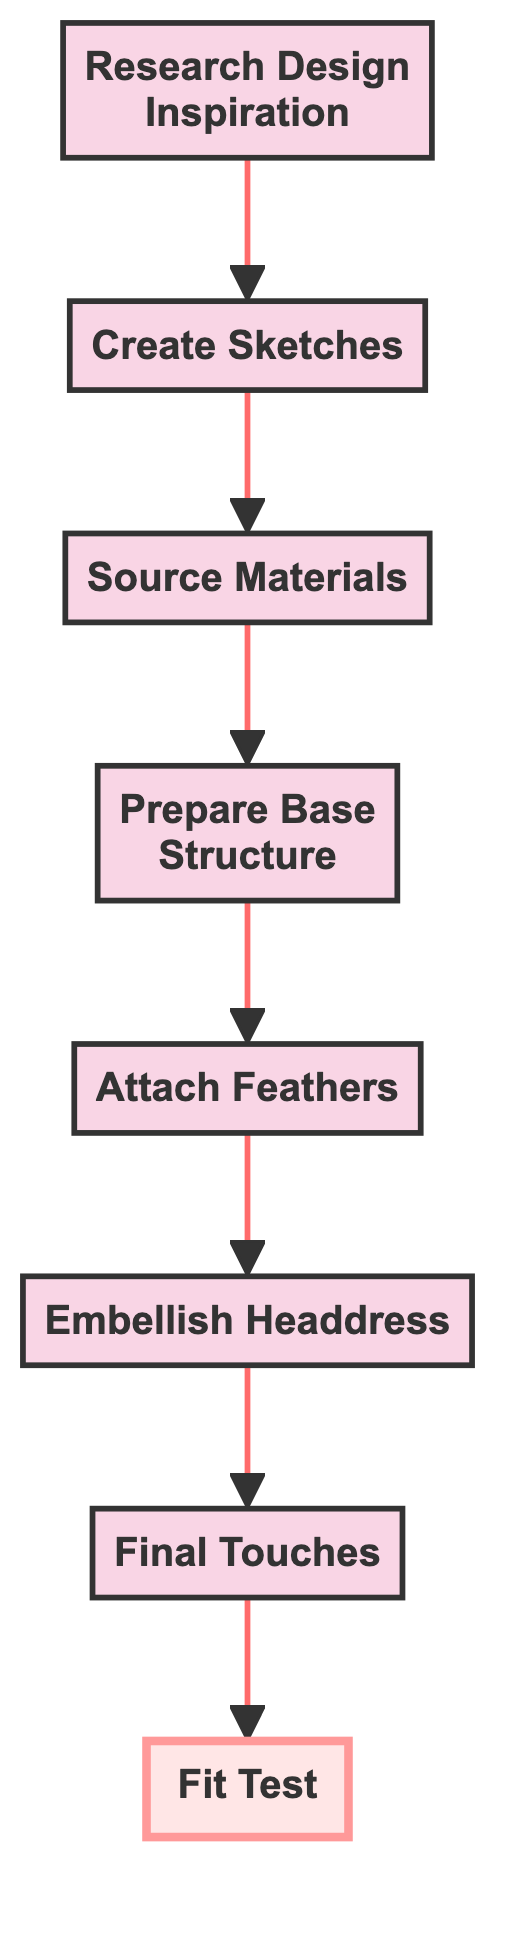What is the first step in constructing the feather headdress? The first step is "Research Design Inspiration," which involves gathering ideas from various sources related to Mardi Gras outfits.
Answer: Research Design Inspiration How many overall steps are in the process? There are a total of eight steps in the flow chart that outline the process of creating a feather headdress.
Answer: Eight What is the penultimate step before the fit test? The penultimate step is "Final Touches," which involves inspecting the headdress and making adjustments for stability and visual appeal.
Answer: Final Touches Which step directly follows sourcing materials? The step that directly follows "Source Materials" is "Prepare Base Structure," which entails creating a sturdy base for the headdress.
Answer: Prepare Base Structure What type of materials do you need to source? You need to source "feathers, base materials, adhesives, and embellishments" to construct the headdress.
Answer: Feathers, base materials, adhesives, embellishments What is the relationship between the "Attach Feathers" step and the "Embellish Headdress" step? "Attach Feathers" comes directly before "Embellish Headdress" in the flow chart, indicating that attaching feathers is a prerequisite for embellishing the headdress.
Answer: Directly before How many decorative items are added in the embelishment step? The specific step refers to "Add sequins, beads, and other decorative items," which suggests multiple items are involved, but it doesn't specify a number.
Answer: Multiple items In which step do you test the comfort and balance of the headdress? The "Fit Test" step is where you test the comfort and balance of the headdress when worn.
Answer: Fit Test 